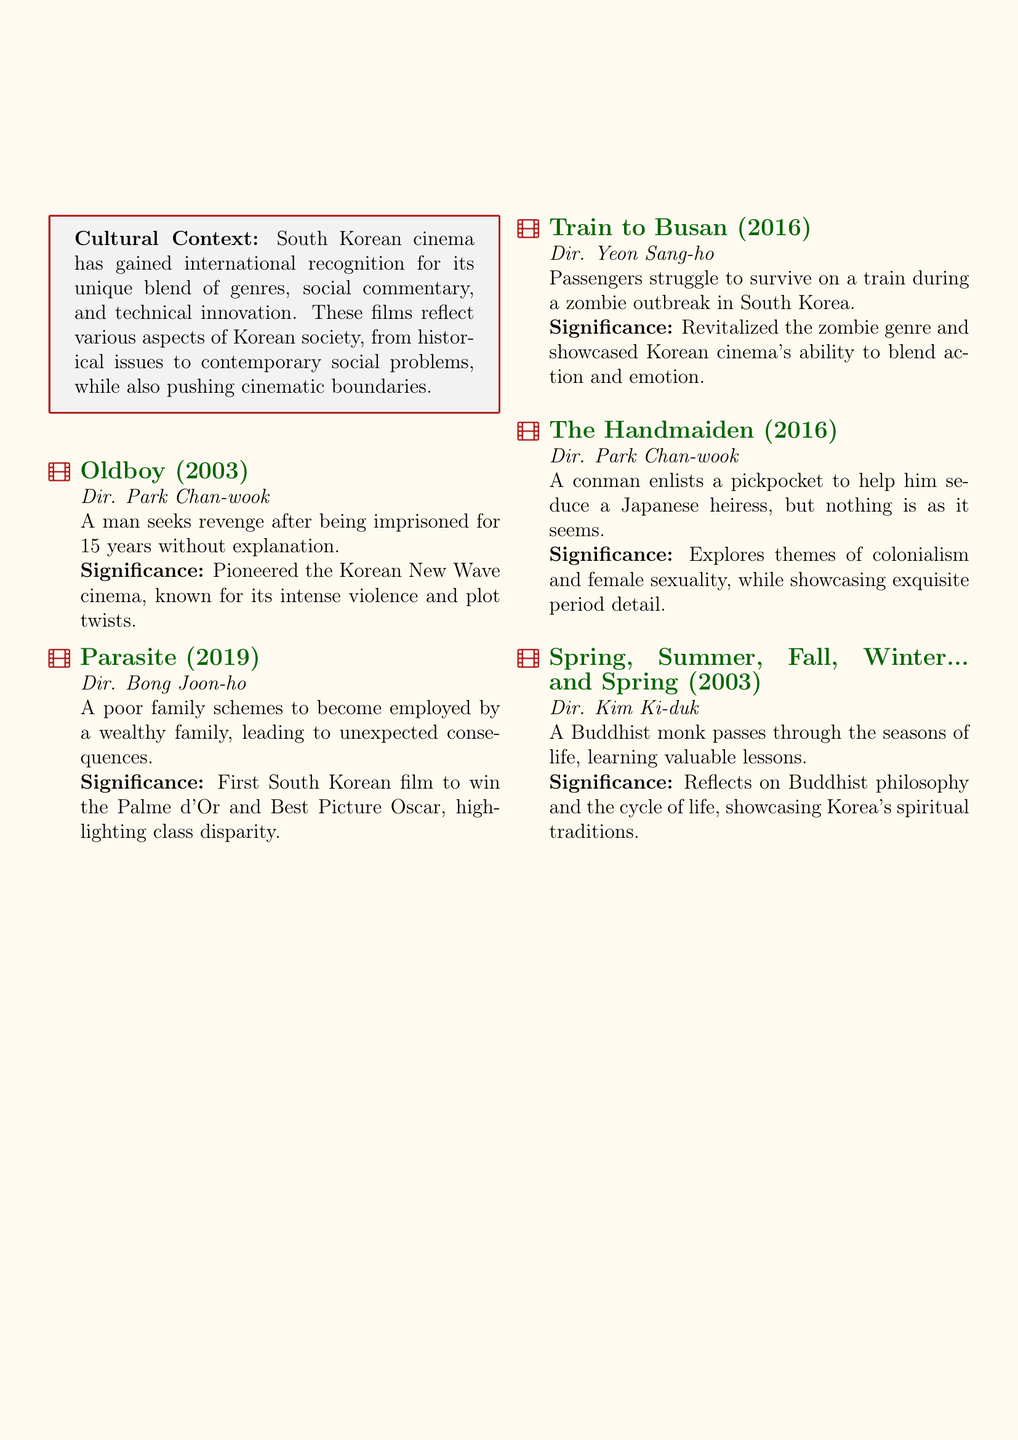What is the title of the film directed by Park Chan-wook released in 2003? The document lists "Oldboy" as the title of the film directed by Park Chan-wook released in 2003.
Answer: Oldboy Who directed the film "Parasite"? The document indicates that "Parasite" was directed by Bong Joon-ho.
Answer: Bong Joon-ho What is the plot of "Train to Busan"? According to the document, the plot involves passengers struggling to survive on a train during a zombie outbreak.
Answer: Zombie outbreak on a train In what year did "Parasite" win the Palme d'Or? The information in the document states that "Parasite" won the Palme d'Or in 2019.
Answer: 2019 What is the cultural context provided for South Korean cinema? The document describes the cultural context as gaining international recognition for its unique blend of genres, social commentary, and technical innovation.
Answer: Unique blend of genres Which film explores themes of colonialism and female sexuality? The document highlights that "The Handmaiden" explores themes of colonialism and female sexuality.
Answer: The Handmaiden What season of life does the monk experience in "Spring, Summer, Fall, Winter... and Spring"? The document explains that the monk passes through the seasons of life learning valuable lessons.
Answer: Seasons of life Which film is the first South Korean film to win an Oscar? The document states that "Parasite" is the first South Korean film to win an Oscar.
Answer: Parasite What genre did "Train to Busan" revitalize? The document mentions that "Train to Busan" revitalized the zombie genre.
Answer: Zombie genre 